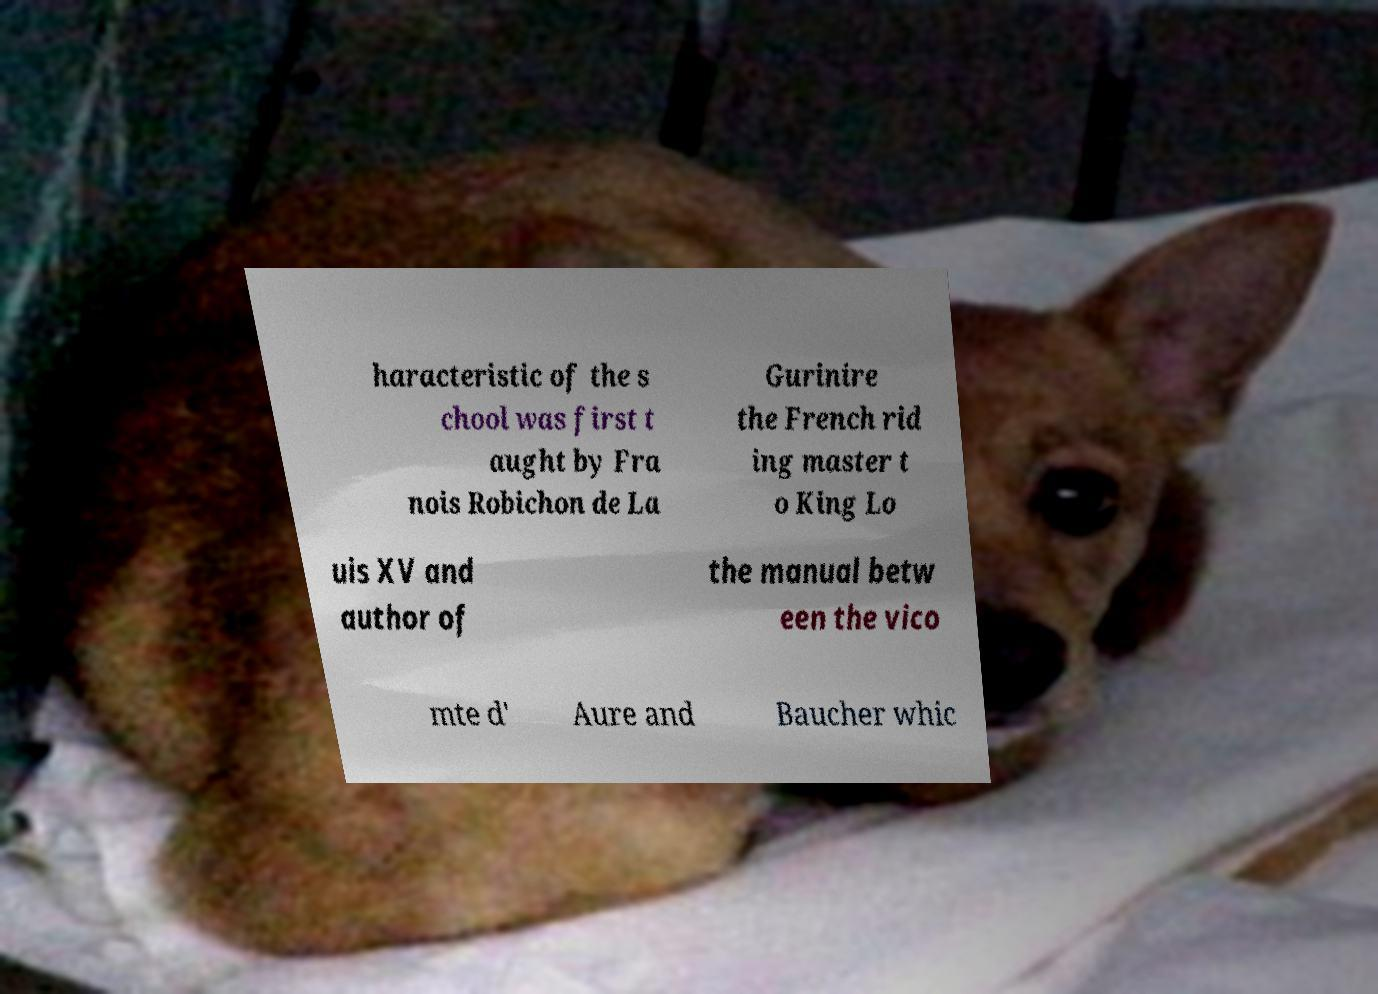What messages or text are displayed in this image? I need them in a readable, typed format. haracteristic of the s chool was first t aught by Fra nois Robichon de La Gurinire the French rid ing master t o King Lo uis XV and author of the manual betw een the vico mte d' Aure and Baucher whic 